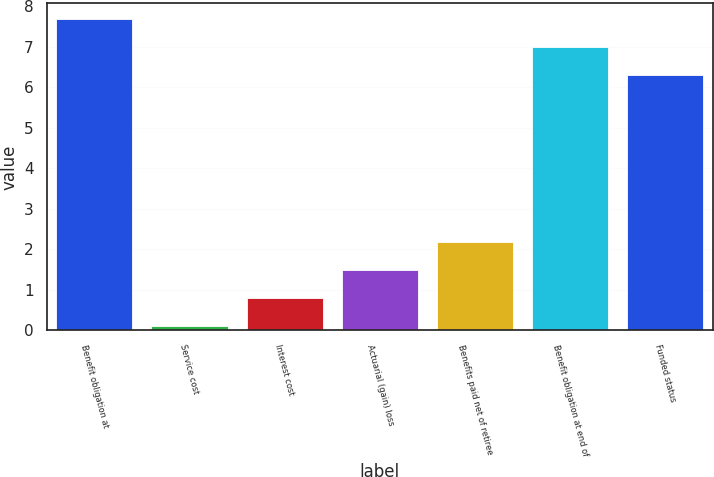<chart> <loc_0><loc_0><loc_500><loc_500><bar_chart><fcel>Benefit obligation at<fcel>Service cost<fcel>Interest cost<fcel>Actuarial (gain) loss<fcel>Benefits paid net of retiree<fcel>Benefit obligation at end of<fcel>Funded status<nl><fcel>7.68<fcel>0.1<fcel>0.79<fcel>1.48<fcel>2.17<fcel>6.99<fcel>6.3<nl></chart> 